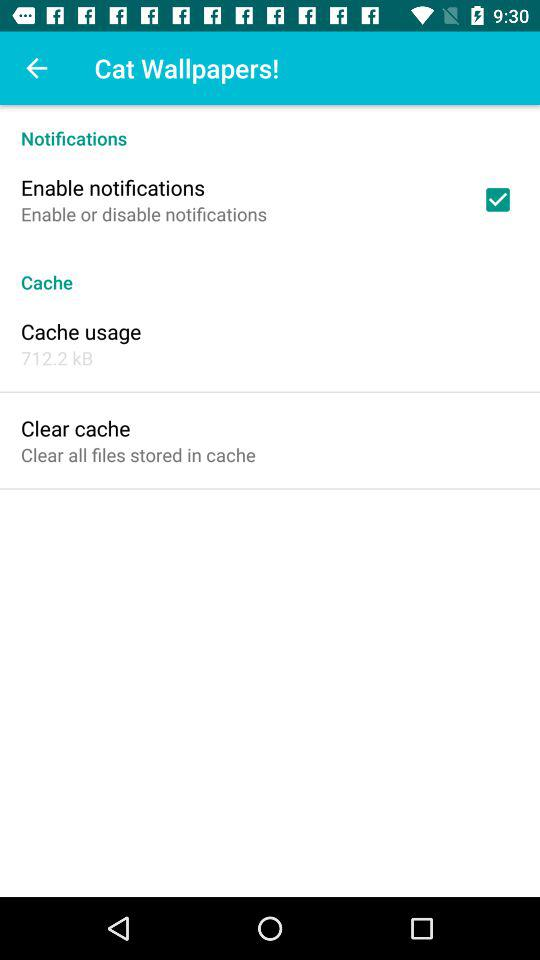How much space does the cache take up?
Answer the question using a single word or phrase. 712.2 kB 